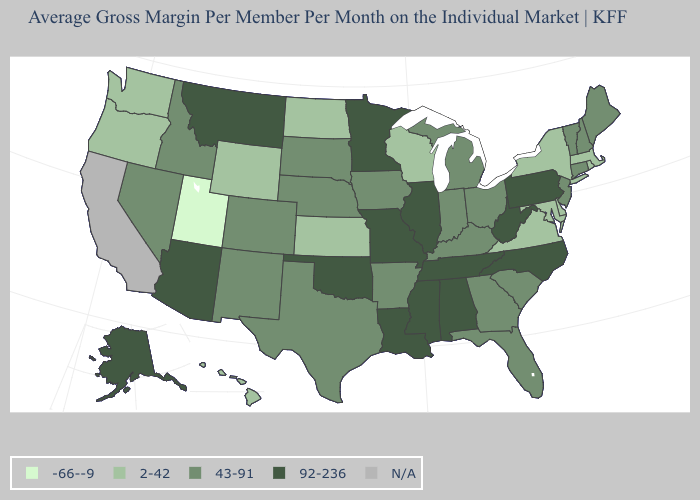What is the value of New York?
Write a very short answer. 2-42. Does Utah have the lowest value in the West?
Quick response, please. Yes. What is the value of North Dakota?
Answer briefly. 2-42. Which states have the lowest value in the USA?
Keep it brief. Utah. Name the states that have a value in the range 43-91?
Be succinct. Arkansas, Colorado, Connecticut, Florida, Georgia, Idaho, Indiana, Iowa, Kentucky, Maine, Michigan, Nebraska, Nevada, New Hampshire, New Jersey, New Mexico, Ohio, South Carolina, South Dakota, Texas, Vermont. What is the highest value in states that border Pennsylvania?
Be succinct. 92-236. What is the lowest value in states that border South Dakota?
Answer briefly. 2-42. What is the lowest value in the USA?
Quick response, please. -66--9. Name the states that have a value in the range 92-236?
Short answer required. Alabama, Alaska, Arizona, Illinois, Louisiana, Minnesota, Mississippi, Missouri, Montana, North Carolina, Oklahoma, Pennsylvania, Tennessee, West Virginia. Name the states that have a value in the range 92-236?
Be succinct. Alabama, Alaska, Arizona, Illinois, Louisiana, Minnesota, Mississippi, Missouri, Montana, North Carolina, Oklahoma, Pennsylvania, Tennessee, West Virginia. Does the map have missing data?
Be succinct. Yes. Name the states that have a value in the range 43-91?
Give a very brief answer. Arkansas, Colorado, Connecticut, Florida, Georgia, Idaho, Indiana, Iowa, Kentucky, Maine, Michigan, Nebraska, Nevada, New Hampshire, New Jersey, New Mexico, Ohio, South Carolina, South Dakota, Texas, Vermont. Does the map have missing data?
Answer briefly. Yes. 